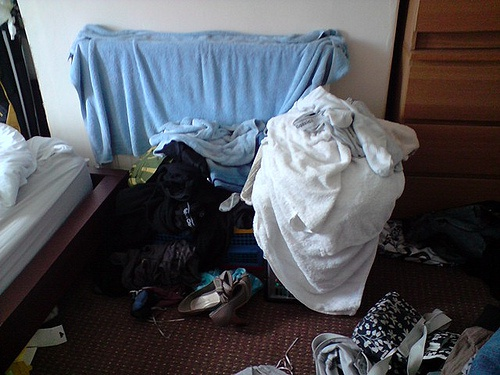Describe the objects in this image and their specific colors. I can see bed in darkgray, black, and gray tones and handbag in darkgray, lightblue, and gray tones in this image. 